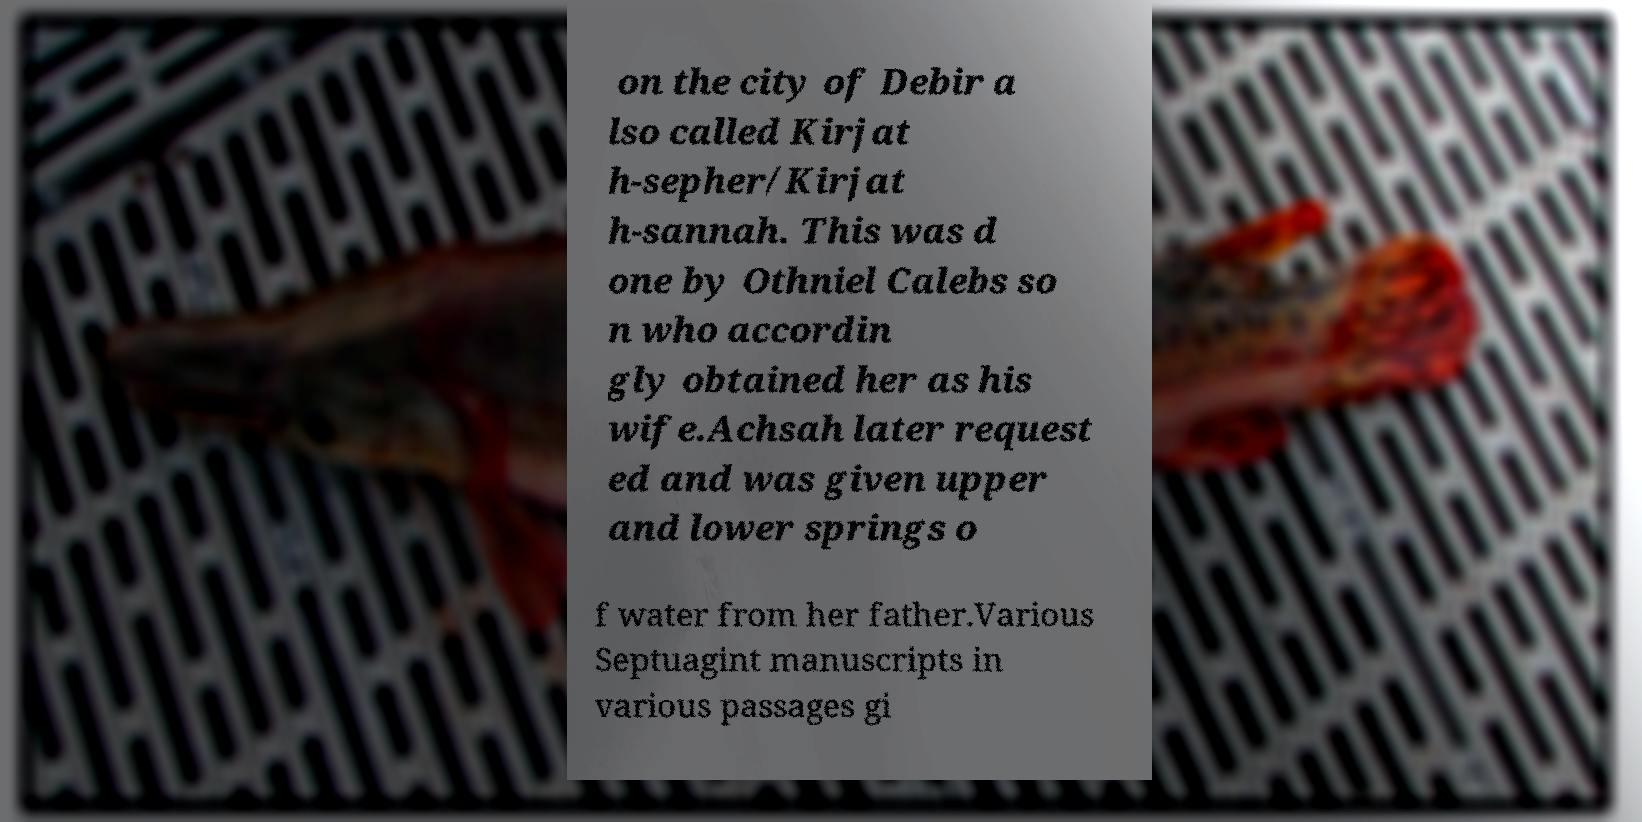There's text embedded in this image that I need extracted. Can you transcribe it verbatim? on the city of Debir a lso called Kirjat h-sepher/Kirjat h-sannah. This was d one by Othniel Calebs so n who accordin gly obtained her as his wife.Achsah later request ed and was given upper and lower springs o f water from her father.Various Septuagint manuscripts in various passages gi 